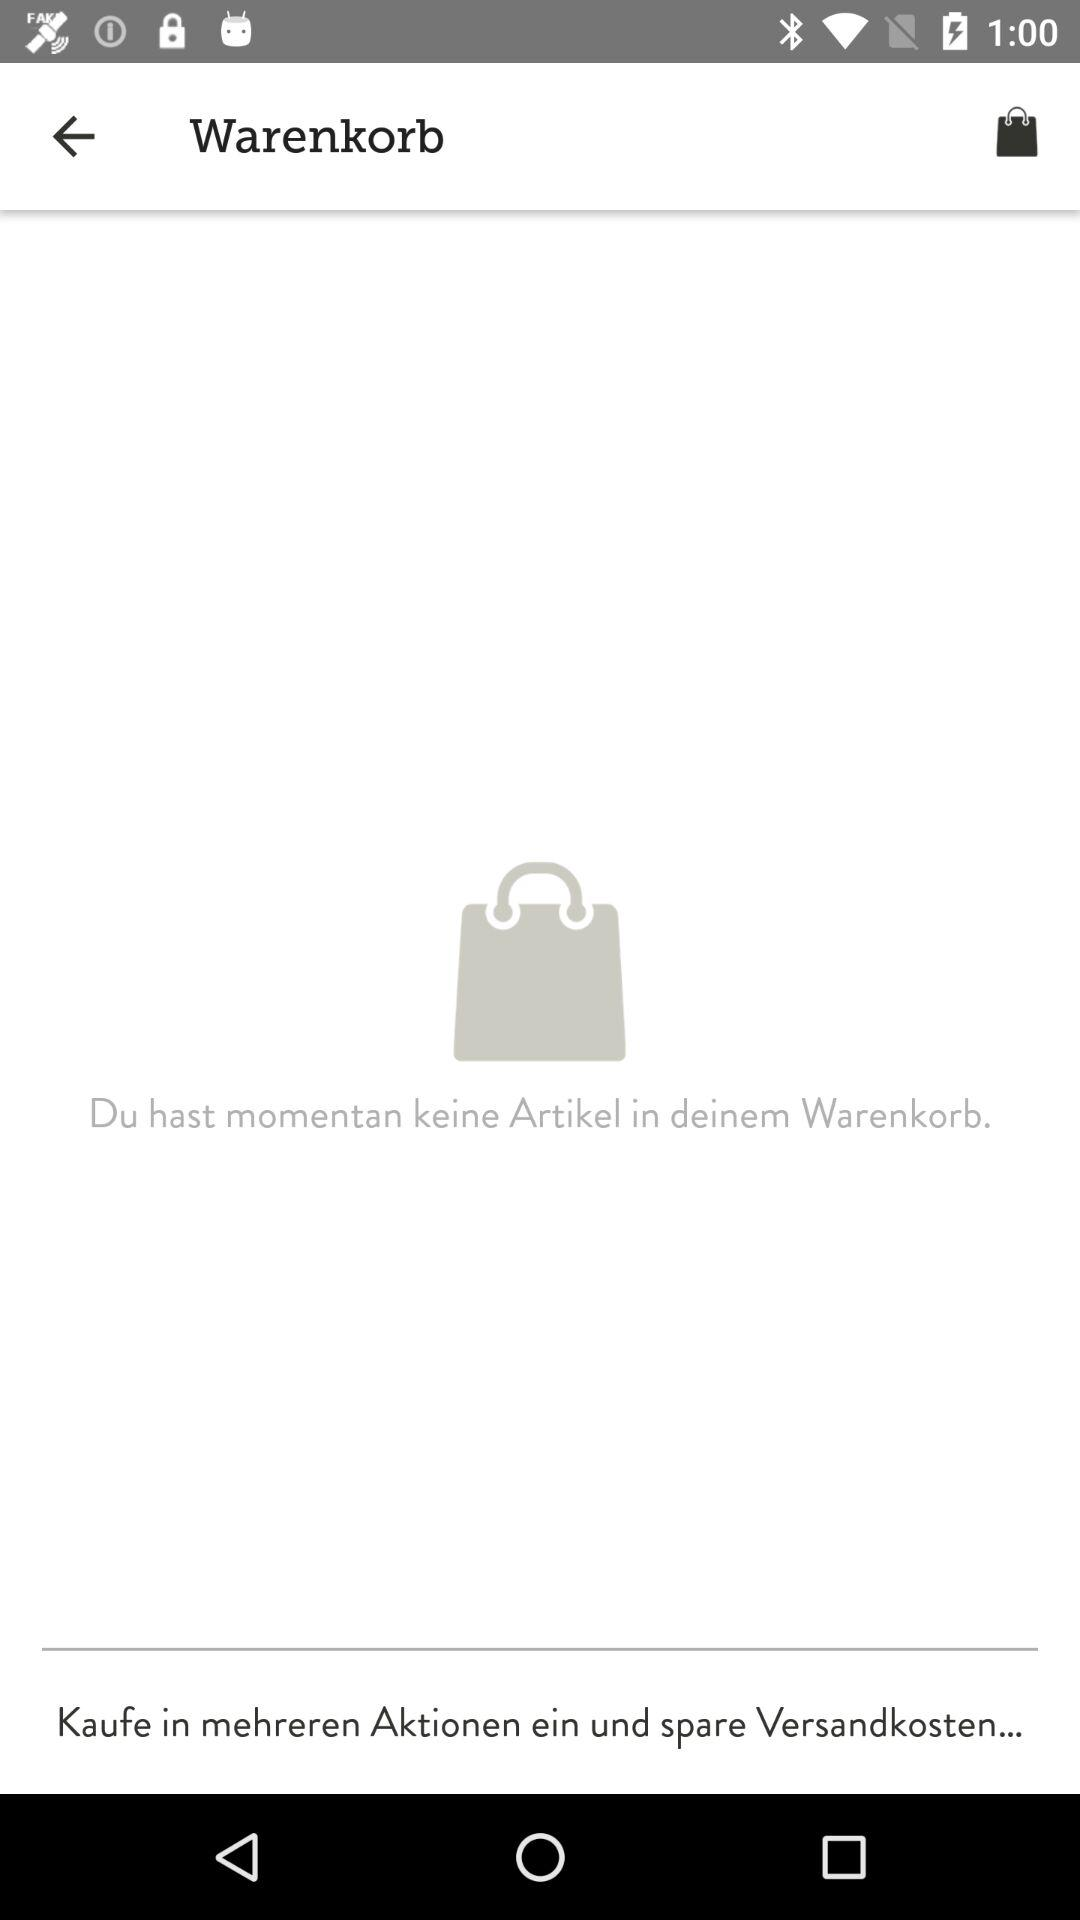How many items are in the shopping cart?
Answer the question using a single word or phrase. 0 